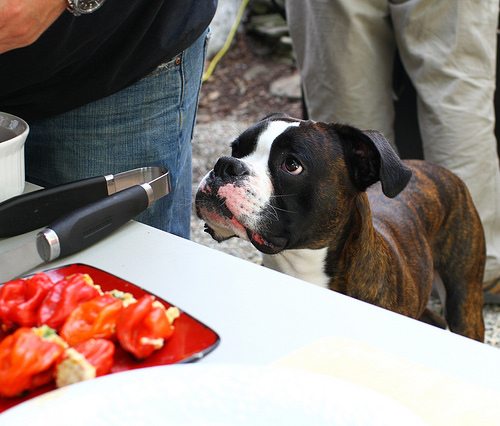<image>
Can you confirm if the peppers is in front of the dog? Yes. The peppers is positioned in front of the dog, appearing closer to the camera viewpoint. 